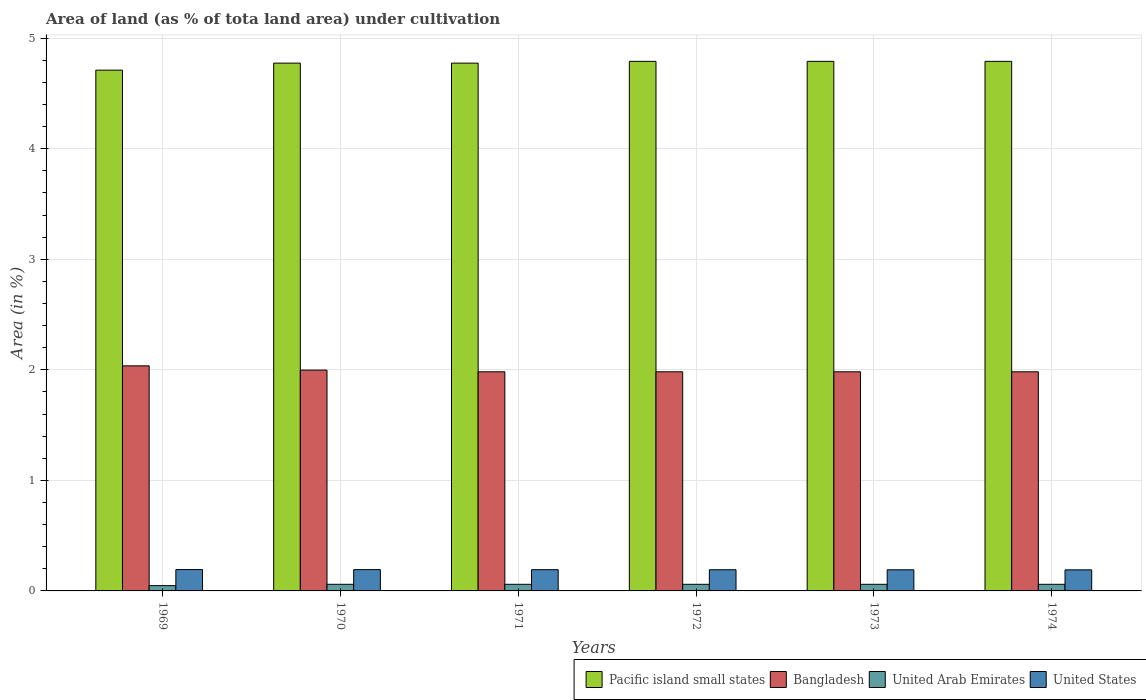How many groups of bars are there?
Your answer should be compact. 6. Are the number of bars per tick equal to the number of legend labels?
Make the answer very short. Yes. How many bars are there on the 6th tick from the left?
Your answer should be compact. 4. What is the label of the 4th group of bars from the left?
Provide a succinct answer. 1972. In how many cases, is the number of bars for a given year not equal to the number of legend labels?
Ensure brevity in your answer.  0. What is the percentage of land under cultivation in United States in 1969?
Your answer should be compact. 0.19. Across all years, what is the maximum percentage of land under cultivation in Pacific island small states?
Your answer should be compact. 4.79. Across all years, what is the minimum percentage of land under cultivation in Bangladesh?
Keep it short and to the point. 1.98. In which year was the percentage of land under cultivation in United States maximum?
Your answer should be compact. 1969. In which year was the percentage of land under cultivation in United States minimum?
Your answer should be very brief. 1974. What is the total percentage of land under cultivation in United States in the graph?
Your answer should be compact. 1.15. What is the difference between the percentage of land under cultivation in United States in 1969 and that in 1970?
Your answer should be very brief. 0. What is the difference between the percentage of land under cultivation in United States in 1973 and the percentage of land under cultivation in United Arab Emirates in 1974?
Your answer should be very brief. 0.13. What is the average percentage of land under cultivation in Pacific island small states per year?
Provide a succinct answer. 4.77. In the year 1970, what is the difference between the percentage of land under cultivation in United Arab Emirates and percentage of land under cultivation in United States?
Make the answer very short. -0.13. What is the ratio of the percentage of land under cultivation in United States in 1970 to that in 1974?
Provide a short and direct response. 1.01. What is the difference between the highest and the second highest percentage of land under cultivation in Pacific island small states?
Your response must be concise. 0. What is the difference between the highest and the lowest percentage of land under cultivation in Pacific island small states?
Offer a terse response. 0.08. In how many years, is the percentage of land under cultivation in Pacific island small states greater than the average percentage of land under cultivation in Pacific island small states taken over all years?
Make the answer very short. 5. Is it the case that in every year, the sum of the percentage of land under cultivation in United Arab Emirates and percentage of land under cultivation in United States is greater than the sum of percentage of land under cultivation in Pacific island small states and percentage of land under cultivation in Bangladesh?
Keep it short and to the point. No. What does the 4th bar from the right in 1972 represents?
Ensure brevity in your answer.  Pacific island small states. How many bars are there?
Ensure brevity in your answer.  24. What is the difference between two consecutive major ticks on the Y-axis?
Provide a short and direct response. 1. Are the values on the major ticks of Y-axis written in scientific E-notation?
Provide a short and direct response. No. Does the graph contain any zero values?
Provide a succinct answer. No. What is the title of the graph?
Your answer should be compact. Area of land (as % of tota land area) under cultivation. Does "Arab World" appear as one of the legend labels in the graph?
Keep it short and to the point. No. What is the label or title of the X-axis?
Your response must be concise. Years. What is the label or title of the Y-axis?
Offer a terse response. Area (in %). What is the Area (in %) of Pacific island small states in 1969?
Offer a terse response. 4.71. What is the Area (in %) in Bangladesh in 1969?
Keep it short and to the point. 2.04. What is the Area (in %) in United Arab Emirates in 1969?
Keep it short and to the point. 0.05. What is the Area (in %) of United States in 1969?
Provide a short and direct response. 0.19. What is the Area (in %) of Pacific island small states in 1970?
Your answer should be very brief. 4.77. What is the Area (in %) of Bangladesh in 1970?
Offer a terse response. 2. What is the Area (in %) in United Arab Emirates in 1970?
Offer a terse response. 0.06. What is the Area (in %) in United States in 1970?
Keep it short and to the point. 0.19. What is the Area (in %) of Pacific island small states in 1971?
Keep it short and to the point. 4.77. What is the Area (in %) in Bangladesh in 1971?
Provide a succinct answer. 1.98. What is the Area (in %) in United Arab Emirates in 1971?
Your response must be concise. 0.06. What is the Area (in %) in United States in 1971?
Offer a terse response. 0.19. What is the Area (in %) in Pacific island small states in 1972?
Make the answer very short. 4.79. What is the Area (in %) in Bangladesh in 1972?
Offer a very short reply. 1.98. What is the Area (in %) of United Arab Emirates in 1972?
Ensure brevity in your answer.  0.06. What is the Area (in %) in United States in 1972?
Ensure brevity in your answer.  0.19. What is the Area (in %) in Pacific island small states in 1973?
Your answer should be very brief. 4.79. What is the Area (in %) in Bangladesh in 1973?
Make the answer very short. 1.98. What is the Area (in %) in United Arab Emirates in 1973?
Make the answer very short. 0.06. What is the Area (in %) in United States in 1973?
Ensure brevity in your answer.  0.19. What is the Area (in %) in Pacific island small states in 1974?
Keep it short and to the point. 4.79. What is the Area (in %) in Bangladesh in 1974?
Offer a terse response. 1.98. What is the Area (in %) of United Arab Emirates in 1974?
Provide a short and direct response. 0.06. What is the Area (in %) of United States in 1974?
Provide a succinct answer. 0.19. Across all years, what is the maximum Area (in %) of Pacific island small states?
Your response must be concise. 4.79. Across all years, what is the maximum Area (in %) in Bangladesh?
Make the answer very short. 2.04. Across all years, what is the maximum Area (in %) of United Arab Emirates?
Make the answer very short. 0.06. Across all years, what is the maximum Area (in %) in United States?
Your response must be concise. 0.19. Across all years, what is the minimum Area (in %) of Pacific island small states?
Make the answer very short. 4.71. Across all years, what is the minimum Area (in %) in Bangladesh?
Provide a short and direct response. 1.98. Across all years, what is the minimum Area (in %) of United Arab Emirates?
Your answer should be very brief. 0.05. Across all years, what is the minimum Area (in %) of United States?
Ensure brevity in your answer.  0.19. What is the total Area (in %) of Pacific island small states in the graph?
Your answer should be compact. 28.63. What is the total Area (in %) of Bangladesh in the graph?
Ensure brevity in your answer.  11.96. What is the total Area (in %) of United Arab Emirates in the graph?
Make the answer very short. 0.35. What is the total Area (in %) in United States in the graph?
Your answer should be compact. 1.15. What is the difference between the Area (in %) in Pacific island small states in 1969 and that in 1970?
Offer a very short reply. -0.06. What is the difference between the Area (in %) in Bangladesh in 1969 and that in 1970?
Provide a succinct answer. 0.04. What is the difference between the Area (in %) of United Arab Emirates in 1969 and that in 1970?
Make the answer very short. -0.01. What is the difference between the Area (in %) in United States in 1969 and that in 1970?
Make the answer very short. 0. What is the difference between the Area (in %) of Pacific island small states in 1969 and that in 1971?
Give a very brief answer. -0.06. What is the difference between the Area (in %) in Bangladesh in 1969 and that in 1971?
Ensure brevity in your answer.  0.05. What is the difference between the Area (in %) in United Arab Emirates in 1969 and that in 1971?
Give a very brief answer. -0.01. What is the difference between the Area (in %) of United States in 1969 and that in 1971?
Your response must be concise. 0. What is the difference between the Area (in %) in Pacific island small states in 1969 and that in 1972?
Provide a succinct answer. -0.08. What is the difference between the Area (in %) in Bangladesh in 1969 and that in 1972?
Keep it short and to the point. 0.05. What is the difference between the Area (in %) of United Arab Emirates in 1969 and that in 1972?
Give a very brief answer. -0.01. What is the difference between the Area (in %) in United States in 1969 and that in 1972?
Offer a terse response. 0. What is the difference between the Area (in %) of Pacific island small states in 1969 and that in 1973?
Offer a terse response. -0.08. What is the difference between the Area (in %) of Bangladesh in 1969 and that in 1973?
Offer a terse response. 0.05. What is the difference between the Area (in %) of United Arab Emirates in 1969 and that in 1973?
Provide a short and direct response. -0.01. What is the difference between the Area (in %) of United States in 1969 and that in 1973?
Make the answer very short. 0. What is the difference between the Area (in %) in Pacific island small states in 1969 and that in 1974?
Make the answer very short. -0.08. What is the difference between the Area (in %) in Bangladesh in 1969 and that in 1974?
Your answer should be compact. 0.05. What is the difference between the Area (in %) in United Arab Emirates in 1969 and that in 1974?
Make the answer very short. -0.01. What is the difference between the Area (in %) of United States in 1969 and that in 1974?
Give a very brief answer. 0. What is the difference between the Area (in %) in Bangladesh in 1970 and that in 1971?
Provide a succinct answer. 0.02. What is the difference between the Area (in %) in United States in 1970 and that in 1971?
Give a very brief answer. 0. What is the difference between the Area (in %) of Pacific island small states in 1970 and that in 1972?
Make the answer very short. -0.02. What is the difference between the Area (in %) in Bangladesh in 1970 and that in 1972?
Offer a very short reply. 0.02. What is the difference between the Area (in %) of United States in 1970 and that in 1972?
Keep it short and to the point. 0. What is the difference between the Area (in %) in Pacific island small states in 1970 and that in 1973?
Your answer should be very brief. -0.02. What is the difference between the Area (in %) of Bangladesh in 1970 and that in 1973?
Make the answer very short. 0.02. What is the difference between the Area (in %) in United Arab Emirates in 1970 and that in 1973?
Give a very brief answer. 0. What is the difference between the Area (in %) in United States in 1970 and that in 1973?
Make the answer very short. 0. What is the difference between the Area (in %) in Pacific island small states in 1970 and that in 1974?
Offer a terse response. -0.02. What is the difference between the Area (in %) in Bangladesh in 1970 and that in 1974?
Give a very brief answer. 0.02. What is the difference between the Area (in %) in United States in 1970 and that in 1974?
Your answer should be very brief. 0. What is the difference between the Area (in %) of Pacific island small states in 1971 and that in 1972?
Keep it short and to the point. -0.02. What is the difference between the Area (in %) in Bangladesh in 1971 and that in 1972?
Your answer should be compact. 0. What is the difference between the Area (in %) of United States in 1971 and that in 1972?
Your answer should be compact. 0. What is the difference between the Area (in %) in Pacific island small states in 1971 and that in 1973?
Your answer should be very brief. -0.02. What is the difference between the Area (in %) in Bangladesh in 1971 and that in 1973?
Provide a succinct answer. 0. What is the difference between the Area (in %) of United States in 1971 and that in 1973?
Offer a very short reply. 0. What is the difference between the Area (in %) of Pacific island small states in 1971 and that in 1974?
Offer a terse response. -0.02. What is the difference between the Area (in %) of United Arab Emirates in 1971 and that in 1974?
Provide a succinct answer. 0. What is the difference between the Area (in %) in United States in 1971 and that in 1974?
Provide a succinct answer. 0. What is the difference between the Area (in %) of Pacific island small states in 1972 and that in 1973?
Offer a very short reply. 0. What is the difference between the Area (in %) of Bangladesh in 1972 and that in 1973?
Provide a short and direct response. 0. What is the difference between the Area (in %) in United States in 1972 and that in 1973?
Provide a succinct answer. 0. What is the difference between the Area (in %) of Bangladesh in 1972 and that in 1974?
Offer a very short reply. 0. What is the difference between the Area (in %) of United Arab Emirates in 1972 and that in 1974?
Provide a succinct answer. 0. What is the difference between the Area (in %) of United States in 1973 and that in 1974?
Your answer should be compact. 0. What is the difference between the Area (in %) in Pacific island small states in 1969 and the Area (in %) in Bangladesh in 1970?
Give a very brief answer. 2.71. What is the difference between the Area (in %) in Pacific island small states in 1969 and the Area (in %) in United Arab Emirates in 1970?
Keep it short and to the point. 4.65. What is the difference between the Area (in %) in Pacific island small states in 1969 and the Area (in %) in United States in 1970?
Keep it short and to the point. 4.52. What is the difference between the Area (in %) in Bangladesh in 1969 and the Area (in %) in United Arab Emirates in 1970?
Provide a succinct answer. 1.98. What is the difference between the Area (in %) in Bangladesh in 1969 and the Area (in %) in United States in 1970?
Give a very brief answer. 1.84. What is the difference between the Area (in %) in United Arab Emirates in 1969 and the Area (in %) in United States in 1970?
Your response must be concise. -0.14. What is the difference between the Area (in %) of Pacific island small states in 1969 and the Area (in %) of Bangladesh in 1971?
Give a very brief answer. 2.73. What is the difference between the Area (in %) of Pacific island small states in 1969 and the Area (in %) of United Arab Emirates in 1971?
Keep it short and to the point. 4.65. What is the difference between the Area (in %) of Pacific island small states in 1969 and the Area (in %) of United States in 1971?
Offer a terse response. 4.52. What is the difference between the Area (in %) in Bangladesh in 1969 and the Area (in %) in United Arab Emirates in 1971?
Your answer should be very brief. 1.98. What is the difference between the Area (in %) in Bangladesh in 1969 and the Area (in %) in United States in 1971?
Ensure brevity in your answer.  1.84. What is the difference between the Area (in %) of United Arab Emirates in 1969 and the Area (in %) of United States in 1971?
Offer a terse response. -0.14. What is the difference between the Area (in %) in Pacific island small states in 1969 and the Area (in %) in Bangladesh in 1972?
Give a very brief answer. 2.73. What is the difference between the Area (in %) of Pacific island small states in 1969 and the Area (in %) of United Arab Emirates in 1972?
Your answer should be very brief. 4.65. What is the difference between the Area (in %) in Pacific island small states in 1969 and the Area (in %) in United States in 1972?
Offer a terse response. 4.52. What is the difference between the Area (in %) in Bangladesh in 1969 and the Area (in %) in United Arab Emirates in 1972?
Offer a very short reply. 1.98. What is the difference between the Area (in %) in Bangladesh in 1969 and the Area (in %) in United States in 1972?
Make the answer very short. 1.84. What is the difference between the Area (in %) in United Arab Emirates in 1969 and the Area (in %) in United States in 1972?
Your answer should be very brief. -0.14. What is the difference between the Area (in %) in Pacific island small states in 1969 and the Area (in %) in Bangladesh in 1973?
Provide a short and direct response. 2.73. What is the difference between the Area (in %) in Pacific island small states in 1969 and the Area (in %) in United Arab Emirates in 1973?
Give a very brief answer. 4.65. What is the difference between the Area (in %) in Pacific island small states in 1969 and the Area (in %) in United States in 1973?
Your answer should be very brief. 4.52. What is the difference between the Area (in %) in Bangladesh in 1969 and the Area (in %) in United Arab Emirates in 1973?
Ensure brevity in your answer.  1.98. What is the difference between the Area (in %) of Bangladesh in 1969 and the Area (in %) of United States in 1973?
Your answer should be very brief. 1.84. What is the difference between the Area (in %) of United Arab Emirates in 1969 and the Area (in %) of United States in 1973?
Your answer should be very brief. -0.14. What is the difference between the Area (in %) of Pacific island small states in 1969 and the Area (in %) of Bangladesh in 1974?
Keep it short and to the point. 2.73. What is the difference between the Area (in %) in Pacific island small states in 1969 and the Area (in %) in United Arab Emirates in 1974?
Ensure brevity in your answer.  4.65. What is the difference between the Area (in %) in Pacific island small states in 1969 and the Area (in %) in United States in 1974?
Your response must be concise. 4.52. What is the difference between the Area (in %) of Bangladesh in 1969 and the Area (in %) of United Arab Emirates in 1974?
Make the answer very short. 1.98. What is the difference between the Area (in %) of Bangladesh in 1969 and the Area (in %) of United States in 1974?
Make the answer very short. 1.85. What is the difference between the Area (in %) of United Arab Emirates in 1969 and the Area (in %) of United States in 1974?
Give a very brief answer. -0.14. What is the difference between the Area (in %) in Pacific island small states in 1970 and the Area (in %) in Bangladesh in 1971?
Give a very brief answer. 2.79. What is the difference between the Area (in %) of Pacific island small states in 1970 and the Area (in %) of United Arab Emirates in 1971?
Offer a terse response. 4.71. What is the difference between the Area (in %) in Pacific island small states in 1970 and the Area (in %) in United States in 1971?
Keep it short and to the point. 4.58. What is the difference between the Area (in %) in Bangladesh in 1970 and the Area (in %) in United Arab Emirates in 1971?
Give a very brief answer. 1.94. What is the difference between the Area (in %) of Bangladesh in 1970 and the Area (in %) of United States in 1971?
Ensure brevity in your answer.  1.81. What is the difference between the Area (in %) in United Arab Emirates in 1970 and the Area (in %) in United States in 1971?
Your response must be concise. -0.13. What is the difference between the Area (in %) in Pacific island small states in 1970 and the Area (in %) in Bangladesh in 1972?
Provide a short and direct response. 2.79. What is the difference between the Area (in %) in Pacific island small states in 1970 and the Area (in %) in United Arab Emirates in 1972?
Your answer should be compact. 4.71. What is the difference between the Area (in %) in Pacific island small states in 1970 and the Area (in %) in United States in 1972?
Keep it short and to the point. 4.58. What is the difference between the Area (in %) in Bangladesh in 1970 and the Area (in %) in United Arab Emirates in 1972?
Make the answer very short. 1.94. What is the difference between the Area (in %) in Bangladesh in 1970 and the Area (in %) in United States in 1972?
Make the answer very short. 1.81. What is the difference between the Area (in %) in United Arab Emirates in 1970 and the Area (in %) in United States in 1972?
Make the answer very short. -0.13. What is the difference between the Area (in %) in Pacific island small states in 1970 and the Area (in %) in Bangladesh in 1973?
Your answer should be compact. 2.79. What is the difference between the Area (in %) of Pacific island small states in 1970 and the Area (in %) of United Arab Emirates in 1973?
Your answer should be very brief. 4.71. What is the difference between the Area (in %) in Pacific island small states in 1970 and the Area (in %) in United States in 1973?
Provide a succinct answer. 4.58. What is the difference between the Area (in %) in Bangladesh in 1970 and the Area (in %) in United Arab Emirates in 1973?
Offer a very short reply. 1.94. What is the difference between the Area (in %) of Bangladesh in 1970 and the Area (in %) of United States in 1973?
Make the answer very short. 1.81. What is the difference between the Area (in %) of United Arab Emirates in 1970 and the Area (in %) of United States in 1973?
Keep it short and to the point. -0.13. What is the difference between the Area (in %) in Pacific island small states in 1970 and the Area (in %) in Bangladesh in 1974?
Offer a very short reply. 2.79. What is the difference between the Area (in %) in Pacific island small states in 1970 and the Area (in %) in United Arab Emirates in 1974?
Keep it short and to the point. 4.71. What is the difference between the Area (in %) of Pacific island small states in 1970 and the Area (in %) of United States in 1974?
Give a very brief answer. 4.58. What is the difference between the Area (in %) in Bangladesh in 1970 and the Area (in %) in United Arab Emirates in 1974?
Your response must be concise. 1.94. What is the difference between the Area (in %) of Bangladesh in 1970 and the Area (in %) of United States in 1974?
Give a very brief answer. 1.81. What is the difference between the Area (in %) of United Arab Emirates in 1970 and the Area (in %) of United States in 1974?
Your answer should be compact. -0.13. What is the difference between the Area (in %) in Pacific island small states in 1971 and the Area (in %) in Bangladesh in 1972?
Provide a short and direct response. 2.79. What is the difference between the Area (in %) of Pacific island small states in 1971 and the Area (in %) of United Arab Emirates in 1972?
Keep it short and to the point. 4.71. What is the difference between the Area (in %) in Pacific island small states in 1971 and the Area (in %) in United States in 1972?
Offer a terse response. 4.58. What is the difference between the Area (in %) of Bangladesh in 1971 and the Area (in %) of United Arab Emirates in 1972?
Ensure brevity in your answer.  1.92. What is the difference between the Area (in %) in Bangladesh in 1971 and the Area (in %) in United States in 1972?
Provide a short and direct response. 1.79. What is the difference between the Area (in %) in United Arab Emirates in 1971 and the Area (in %) in United States in 1972?
Offer a very short reply. -0.13. What is the difference between the Area (in %) in Pacific island small states in 1971 and the Area (in %) in Bangladesh in 1973?
Your response must be concise. 2.79. What is the difference between the Area (in %) of Pacific island small states in 1971 and the Area (in %) of United Arab Emirates in 1973?
Offer a very short reply. 4.71. What is the difference between the Area (in %) in Pacific island small states in 1971 and the Area (in %) in United States in 1973?
Give a very brief answer. 4.58. What is the difference between the Area (in %) in Bangladesh in 1971 and the Area (in %) in United Arab Emirates in 1973?
Provide a short and direct response. 1.92. What is the difference between the Area (in %) in Bangladesh in 1971 and the Area (in %) in United States in 1973?
Offer a very short reply. 1.79. What is the difference between the Area (in %) of United Arab Emirates in 1971 and the Area (in %) of United States in 1973?
Ensure brevity in your answer.  -0.13. What is the difference between the Area (in %) in Pacific island small states in 1971 and the Area (in %) in Bangladesh in 1974?
Your answer should be compact. 2.79. What is the difference between the Area (in %) in Pacific island small states in 1971 and the Area (in %) in United Arab Emirates in 1974?
Your answer should be compact. 4.71. What is the difference between the Area (in %) in Pacific island small states in 1971 and the Area (in %) in United States in 1974?
Offer a very short reply. 4.58. What is the difference between the Area (in %) of Bangladesh in 1971 and the Area (in %) of United Arab Emirates in 1974?
Provide a succinct answer. 1.92. What is the difference between the Area (in %) in Bangladesh in 1971 and the Area (in %) in United States in 1974?
Give a very brief answer. 1.79. What is the difference between the Area (in %) of United Arab Emirates in 1971 and the Area (in %) of United States in 1974?
Keep it short and to the point. -0.13. What is the difference between the Area (in %) of Pacific island small states in 1972 and the Area (in %) of Bangladesh in 1973?
Your answer should be compact. 2.81. What is the difference between the Area (in %) in Pacific island small states in 1972 and the Area (in %) in United Arab Emirates in 1973?
Give a very brief answer. 4.73. What is the difference between the Area (in %) in Pacific island small states in 1972 and the Area (in %) in United States in 1973?
Offer a very short reply. 4.6. What is the difference between the Area (in %) in Bangladesh in 1972 and the Area (in %) in United Arab Emirates in 1973?
Offer a very short reply. 1.92. What is the difference between the Area (in %) in Bangladesh in 1972 and the Area (in %) in United States in 1973?
Your answer should be very brief. 1.79. What is the difference between the Area (in %) of United Arab Emirates in 1972 and the Area (in %) of United States in 1973?
Give a very brief answer. -0.13. What is the difference between the Area (in %) in Pacific island small states in 1972 and the Area (in %) in Bangladesh in 1974?
Your answer should be very brief. 2.81. What is the difference between the Area (in %) in Pacific island small states in 1972 and the Area (in %) in United Arab Emirates in 1974?
Offer a terse response. 4.73. What is the difference between the Area (in %) of Pacific island small states in 1972 and the Area (in %) of United States in 1974?
Your answer should be compact. 4.6. What is the difference between the Area (in %) of Bangladesh in 1972 and the Area (in %) of United Arab Emirates in 1974?
Provide a short and direct response. 1.92. What is the difference between the Area (in %) of Bangladesh in 1972 and the Area (in %) of United States in 1974?
Provide a short and direct response. 1.79. What is the difference between the Area (in %) in United Arab Emirates in 1972 and the Area (in %) in United States in 1974?
Keep it short and to the point. -0.13. What is the difference between the Area (in %) in Pacific island small states in 1973 and the Area (in %) in Bangladesh in 1974?
Your answer should be compact. 2.81. What is the difference between the Area (in %) of Pacific island small states in 1973 and the Area (in %) of United Arab Emirates in 1974?
Give a very brief answer. 4.73. What is the difference between the Area (in %) of Pacific island small states in 1973 and the Area (in %) of United States in 1974?
Make the answer very short. 4.6. What is the difference between the Area (in %) in Bangladesh in 1973 and the Area (in %) in United Arab Emirates in 1974?
Your answer should be compact. 1.92. What is the difference between the Area (in %) in Bangladesh in 1973 and the Area (in %) in United States in 1974?
Offer a terse response. 1.79. What is the difference between the Area (in %) in United Arab Emirates in 1973 and the Area (in %) in United States in 1974?
Provide a succinct answer. -0.13. What is the average Area (in %) of Pacific island small states per year?
Give a very brief answer. 4.77. What is the average Area (in %) in Bangladesh per year?
Give a very brief answer. 1.99. What is the average Area (in %) of United Arab Emirates per year?
Ensure brevity in your answer.  0.06. What is the average Area (in %) in United States per year?
Keep it short and to the point. 0.19. In the year 1969, what is the difference between the Area (in %) of Pacific island small states and Area (in %) of Bangladesh?
Your answer should be very brief. 2.67. In the year 1969, what is the difference between the Area (in %) in Pacific island small states and Area (in %) in United Arab Emirates?
Your answer should be compact. 4.66. In the year 1969, what is the difference between the Area (in %) in Pacific island small states and Area (in %) in United States?
Your answer should be compact. 4.52. In the year 1969, what is the difference between the Area (in %) of Bangladesh and Area (in %) of United Arab Emirates?
Your answer should be compact. 1.99. In the year 1969, what is the difference between the Area (in %) of Bangladesh and Area (in %) of United States?
Make the answer very short. 1.84. In the year 1969, what is the difference between the Area (in %) of United Arab Emirates and Area (in %) of United States?
Provide a short and direct response. -0.15. In the year 1970, what is the difference between the Area (in %) in Pacific island small states and Area (in %) in Bangladesh?
Keep it short and to the point. 2.78. In the year 1970, what is the difference between the Area (in %) in Pacific island small states and Area (in %) in United Arab Emirates?
Provide a succinct answer. 4.71. In the year 1970, what is the difference between the Area (in %) in Pacific island small states and Area (in %) in United States?
Keep it short and to the point. 4.58. In the year 1970, what is the difference between the Area (in %) of Bangladesh and Area (in %) of United Arab Emirates?
Your answer should be compact. 1.94. In the year 1970, what is the difference between the Area (in %) of Bangladesh and Area (in %) of United States?
Make the answer very short. 1.8. In the year 1970, what is the difference between the Area (in %) in United Arab Emirates and Area (in %) in United States?
Provide a short and direct response. -0.13. In the year 1971, what is the difference between the Area (in %) in Pacific island small states and Area (in %) in Bangladesh?
Keep it short and to the point. 2.79. In the year 1971, what is the difference between the Area (in %) in Pacific island small states and Area (in %) in United Arab Emirates?
Offer a terse response. 4.71. In the year 1971, what is the difference between the Area (in %) in Pacific island small states and Area (in %) in United States?
Offer a terse response. 4.58. In the year 1971, what is the difference between the Area (in %) of Bangladesh and Area (in %) of United Arab Emirates?
Your response must be concise. 1.92. In the year 1971, what is the difference between the Area (in %) of Bangladesh and Area (in %) of United States?
Your response must be concise. 1.79. In the year 1971, what is the difference between the Area (in %) of United Arab Emirates and Area (in %) of United States?
Your response must be concise. -0.13. In the year 1972, what is the difference between the Area (in %) in Pacific island small states and Area (in %) in Bangladesh?
Provide a succinct answer. 2.81. In the year 1972, what is the difference between the Area (in %) in Pacific island small states and Area (in %) in United Arab Emirates?
Give a very brief answer. 4.73. In the year 1972, what is the difference between the Area (in %) of Pacific island small states and Area (in %) of United States?
Your answer should be very brief. 4.6. In the year 1972, what is the difference between the Area (in %) of Bangladesh and Area (in %) of United Arab Emirates?
Keep it short and to the point. 1.92. In the year 1972, what is the difference between the Area (in %) in Bangladesh and Area (in %) in United States?
Provide a short and direct response. 1.79. In the year 1972, what is the difference between the Area (in %) of United Arab Emirates and Area (in %) of United States?
Ensure brevity in your answer.  -0.13. In the year 1973, what is the difference between the Area (in %) of Pacific island small states and Area (in %) of Bangladesh?
Your answer should be very brief. 2.81. In the year 1973, what is the difference between the Area (in %) in Pacific island small states and Area (in %) in United Arab Emirates?
Offer a very short reply. 4.73. In the year 1973, what is the difference between the Area (in %) of Pacific island small states and Area (in %) of United States?
Provide a succinct answer. 4.6. In the year 1973, what is the difference between the Area (in %) in Bangladesh and Area (in %) in United Arab Emirates?
Provide a succinct answer. 1.92. In the year 1973, what is the difference between the Area (in %) of Bangladesh and Area (in %) of United States?
Your response must be concise. 1.79. In the year 1973, what is the difference between the Area (in %) of United Arab Emirates and Area (in %) of United States?
Offer a terse response. -0.13. In the year 1974, what is the difference between the Area (in %) of Pacific island small states and Area (in %) of Bangladesh?
Give a very brief answer. 2.81. In the year 1974, what is the difference between the Area (in %) of Pacific island small states and Area (in %) of United Arab Emirates?
Keep it short and to the point. 4.73. In the year 1974, what is the difference between the Area (in %) in Pacific island small states and Area (in %) in United States?
Your response must be concise. 4.6. In the year 1974, what is the difference between the Area (in %) of Bangladesh and Area (in %) of United Arab Emirates?
Your response must be concise. 1.92. In the year 1974, what is the difference between the Area (in %) of Bangladesh and Area (in %) of United States?
Offer a very short reply. 1.79. In the year 1974, what is the difference between the Area (in %) in United Arab Emirates and Area (in %) in United States?
Give a very brief answer. -0.13. What is the ratio of the Area (in %) of Pacific island small states in 1969 to that in 1970?
Provide a succinct answer. 0.99. What is the ratio of the Area (in %) of Bangladesh in 1969 to that in 1970?
Give a very brief answer. 1.02. What is the ratio of the Area (in %) of United Arab Emirates in 1969 to that in 1970?
Offer a very short reply. 0.8. What is the ratio of the Area (in %) in Pacific island small states in 1969 to that in 1971?
Provide a short and direct response. 0.99. What is the ratio of the Area (in %) of Bangladesh in 1969 to that in 1971?
Give a very brief answer. 1.03. What is the ratio of the Area (in %) of United Arab Emirates in 1969 to that in 1971?
Make the answer very short. 0.8. What is the ratio of the Area (in %) in Pacific island small states in 1969 to that in 1972?
Offer a very short reply. 0.98. What is the ratio of the Area (in %) in Bangladesh in 1969 to that in 1972?
Your answer should be compact. 1.03. What is the ratio of the Area (in %) in United States in 1969 to that in 1972?
Provide a short and direct response. 1.01. What is the ratio of the Area (in %) in Pacific island small states in 1969 to that in 1973?
Provide a short and direct response. 0.98. What is the ratio of the Area (in %) of Bangladesh in 1969 to that in 1973?
Ensure brevity in your answer.  1.03. What is the ratio of the Area (in %) of United Arab Emirates in 1969 to that in 1973?
Give a very brief answer. 0.8. What is the ratio of the Area (in %) in United States in 1969 to that in 1973?
Your answer should be very brief. 1.01. What is the ratio of the Area (in %) of Pacific island small states in 1969 to that in 1974?
Your response must be concise. 0.98. What is the ratio of the Area (in %) in Bangladesh in 1969 to that in 1974?
Offer a terse response. 1.03. What is the ratio of the Area (in %) of United States in 1969 to that in 1974?
Offer a very short reply. 1.01. What is the ratio of the Area (in %) of Bangladesh in 1970 to that in 1971?
Offer a very short reply. 1.01. What is the ratio of the Area (in %) in Pacific island small states in 1970 to that in 1972?
Provide a short and direct response. 1. What is the ratio of the Area (in %) in United Arab Emirates in 1970 to that in 1972?
Your answer should be very brief. 1. What is the ratio of the Area (in %) in Pacific island small states in 1970 to that in 1973?
Your answer should be compact. 1. What is the ratio of the Area (in %) in Bangladesh in 1970 to that in 1973?
Ensure brevity in your answer.  1.01. What is the ratio of the Area (in %) in United Arab Emirates in 1970 to that in 1973?
Keep it short and to the point. 1. What is the ratio of the Area (in %) in United States in 1970 to that in 1973?
Ensure brevity in your answer.  1.01. What is the ratio of the Area (in %) of United Arab Emirates in 1970 to that in 1974?
Give a very brief answer. 1. What is the ratio of the Area (in %) of United States in 1970 to that in 1974?
Ensure brevity in your answer.  1.01. What is the ratio of the Area (in %) of United States in 1971 to that in 1972?
Make the answer very short. 1. What is the ratio of the Area (in %) in Pacific island small states in 1971 to that in 1974?
Ensure brevity in your answer.  1. What is the ratio of the Area (in %) of Bangladesh in 1971 to that in 1974?
Provide a short and direct response. 1. What is the ratio of the Area (in %) of Pacific island small states in 1972 to that in 1973?
Your answer should be compact. 1. What is the ratio of the Area (in %) of Bangladesh in 1972 to that in 1973?
Provide a succinct answer. 1. What is the ratio of the Area (in %) of United States in 1972 to that in 1973?
Offer a very short reply. 1. What is the ratio of the Area (in %) in Bangladesh in 1972 to that in 1974?
Provide a short and direct response. 1. What is the ratio of the Area (in %) in United Arab Emirates in 1973 to that in 1974?
Offer a terse response. 1. What is the ratio of the Area (in %) in United States in 1973 to that in 1974?
Ensure brevity in your answer.  1. What is the difference between the highest and the second highest Area (in %) of Pacific island small states?
Give a very brief answer. 0. What is the difference between the highest and the second highest Area (in %) of Bangladesh?
Your answer should be compact. 0.04. What is the difference between the highest and the second highest Area (in %) in United States?
Your answer should be very brief. 0. What is the difference between the highest and the lowest Area (in %) of Pacific island small states?
Provide a short and direct response. 0.08. What is the difference between the highest and the lowest Area (in %) in Bangladesh?
Make the answer very short. 0.05. What is the difference between the highest and the lowest Area (in %) in United Arab Emirates?
Provide a succinct answer. 0.01. What is the difference between the highest and the lowest Area (in %) in United States?
Provide a short and direct response. 0. 